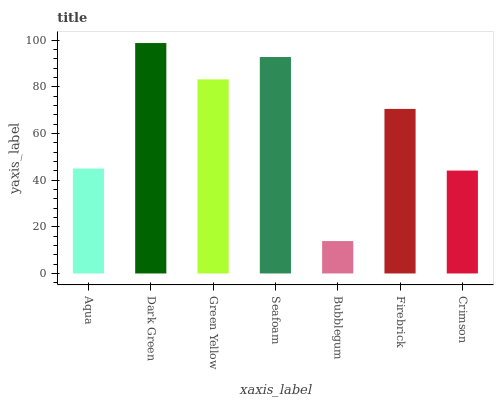Is Bubblegum the minimum?
Answer yes or no. Yes. Is Dark Green the maximum?
Answer yes or no. Yes. Is Green Yellow the minimum?
Answer yes or no. No. Is Green Yellow the maximum?
Answer yes or no. No. Is Dark Green greater than Green Yellow?
Answer yes or no. Yes. Is Green Yellow less than Dark Green?
Answer yes or no. Yes. Is Green Yellow greater than Dark Green?
Answer yes or no. No. Is Dark Green less than Green Yellow?
Answer yes or no. No. Is Firebrick the high median?
Answer yes or no. Yes. Is Firebrick the low median?
Answer yes or no. Yes. Is Crimson the high median?
Answer yes or no. No. Is Crimson the low median?
Answer yes or no. No. 